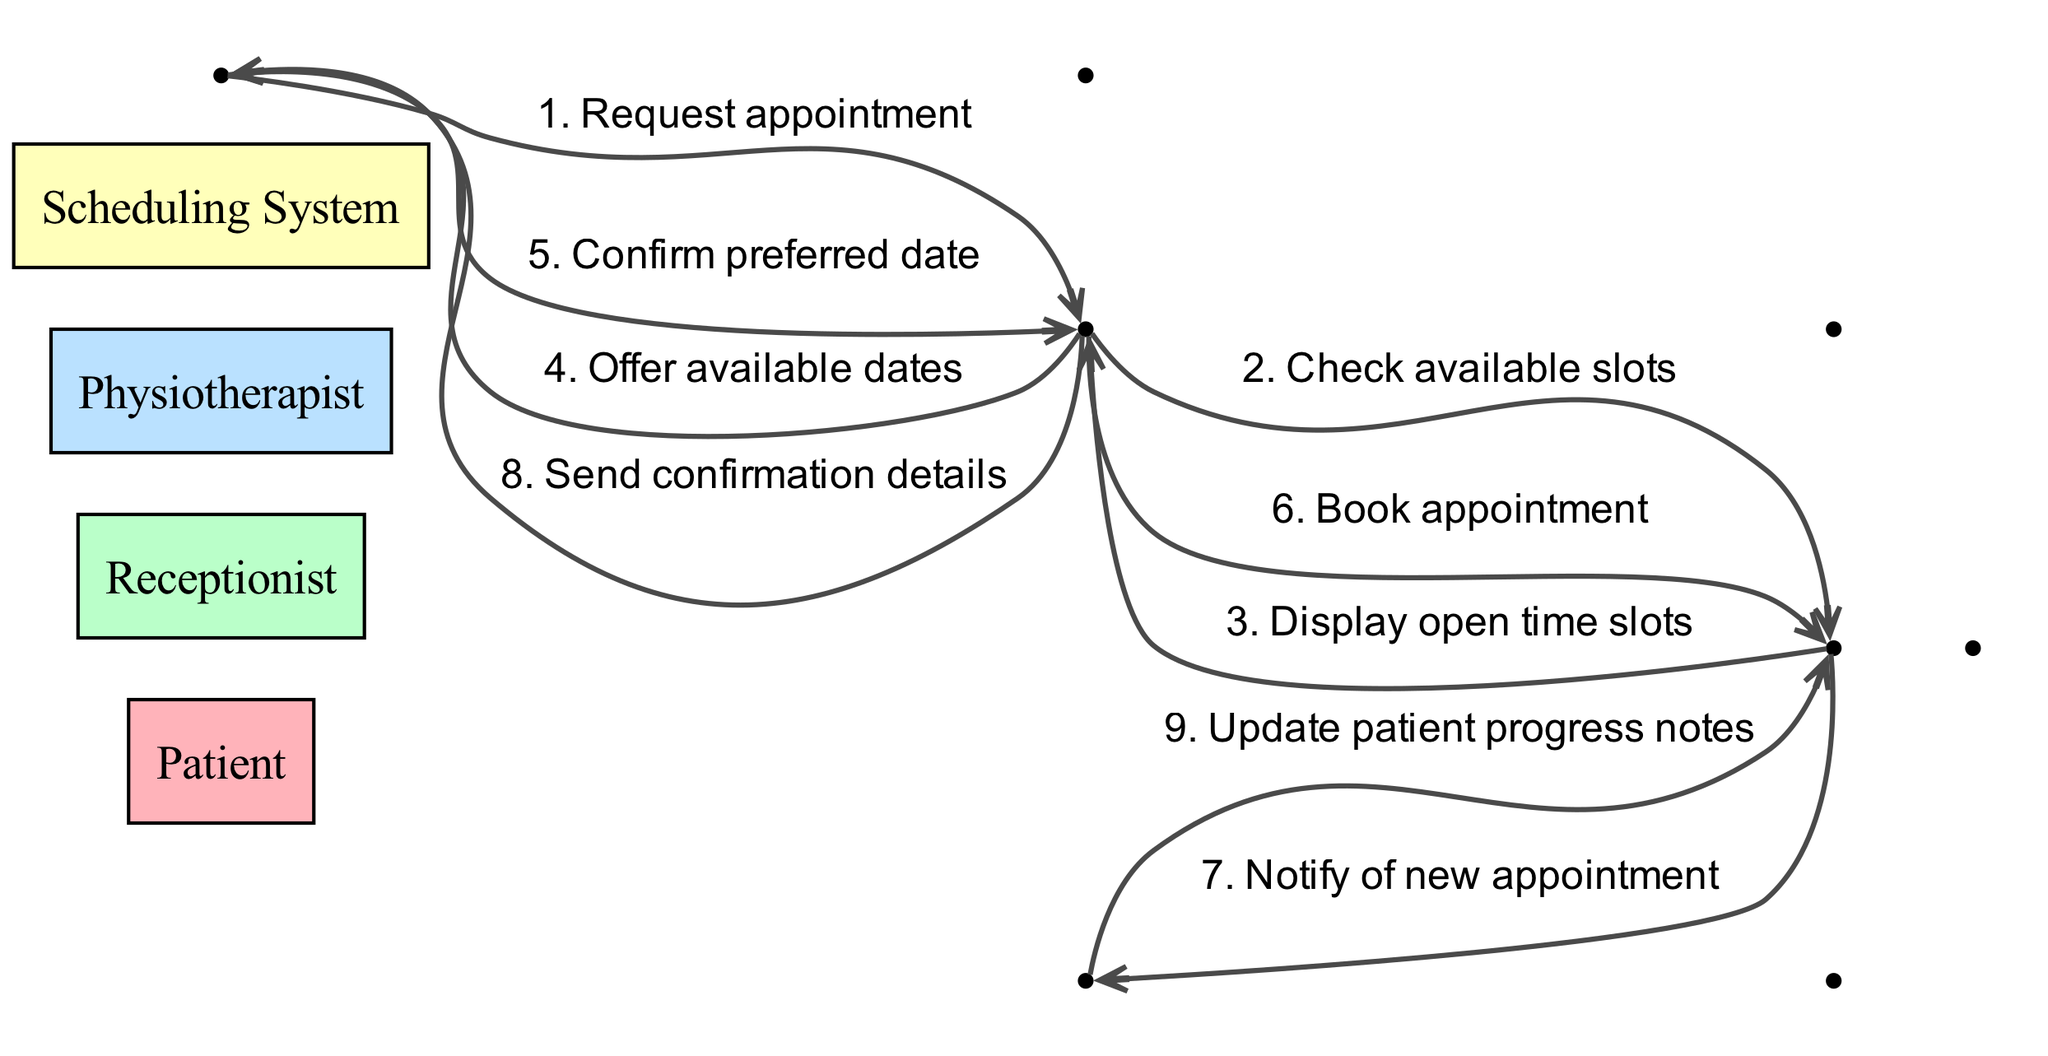What is the first action taken by the Patient? The first action taken by the Patient is to request an appointment. This action is indicated as the first message in the sequence flow where the Patient sends a request to the Receptionist.
Answer: Request appointment How many actors are involved in the sequence diagram? The diagram includes four actors: Patient, Receptionist, Physiotherapist, and Scheduling System. This can be counted directly from the list of actors provided in the data.
Answer: Four Who does the Receptionist notify after booking an appointment? After booking an appointment, the Receptionist notifies the Physiotherapist by sending a message indicating a new appointment. This relationship is shown in the sequence flow from the Scheduling System to the Physiotherapist.
Answer: Physiotherapist What message does the Scheduling System send to the Receptionist after checking for available slots? The Scheduling System sends the message "Display open time slots" to the Receptionist. This can be found as the third message in the sequence.
Answer: Display open time slots What is the last action in the sequence performed by the Physiotherapist? The last action in the sequence performed by the Physiotherapist is to update the patient progress notes. This action is represented as the final message in the flow of the diagram.
Answer: Update patient progress notes How does the Patient respond to the offered available dates? The Patient confirms their preferred date after being offered the available dates by the Receptionist. This response is indicated as message number five in the sequence.
Answer: Confirm preferred date What happens after the Receptionist sends confirmation details to the Patient? The confirmation details sent to the Patient signify the conclusion of the appointment scheduling process. However, it does not lead to any further actions in the context of this specific diagram as it is the last message that involves the Patient.
Answer: End of sequence Which system checks for available appointment slots? The Scheduling System checks for available appointment slots at the request of the Receptionist. This is shown as the second message in the sequence between the Receptionist and the Scheduling System.
Answer: Scheduling System What does the Receptionist offer to the Patient? The Receptionist offers available dates to the Patient after checking the slots. This is specifically noted in the fourth message exchanged in the sequence.
Answer: Offer available dates 